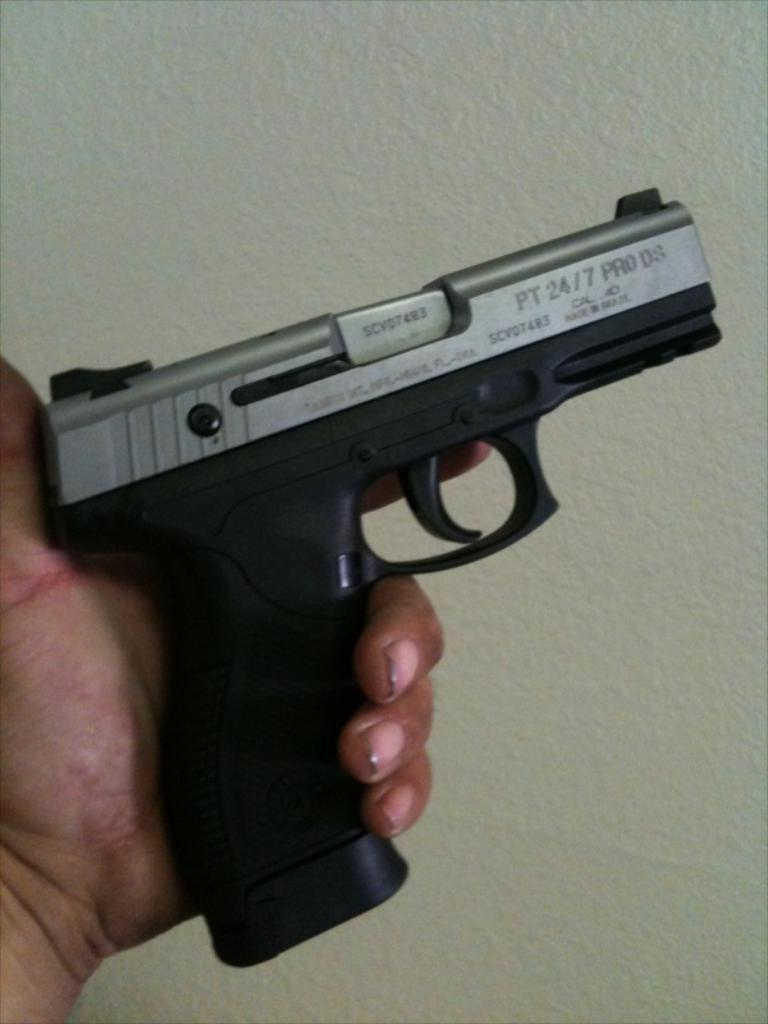What is the person's hand holding in the image? There is a person's hand holding a pistol in the image. What can be seen in the background of the image? There is a wall in the background of the image. What type of cheese is the squirrel eating near the wall in the image? There is no squirrel or cheese present in the image. 